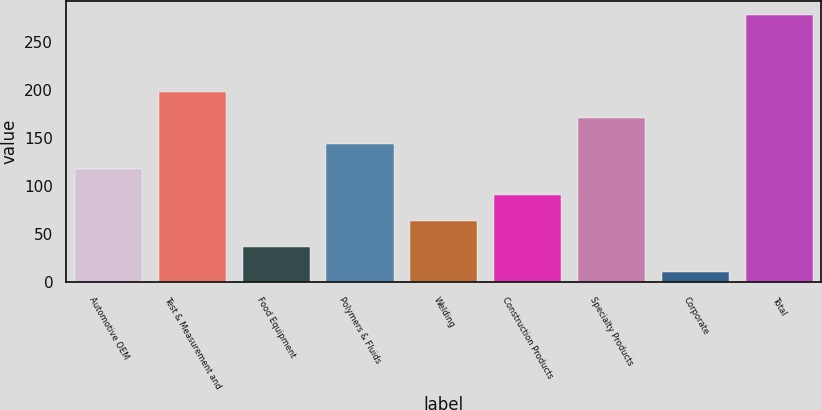Convert chart. <chart><loc_0><loc_0><loc_500><loc_500><bar_chart><fcel>Automotive OEM<fcel>Test & Measurement and<fcel>Food Equipment<fcel>Polymers & Fluids<fcel>Welding<fcel>Construction Products<fcel>Specialty Products<fcel>Corporate<fcel>Total<nl><fcel>117.2<fcel>197.6<fcel>36.8<fcel>144<fcel>63.6<fcel>90.4<fcel>170.8<fcel>10<fcel>278<nl></chart> 